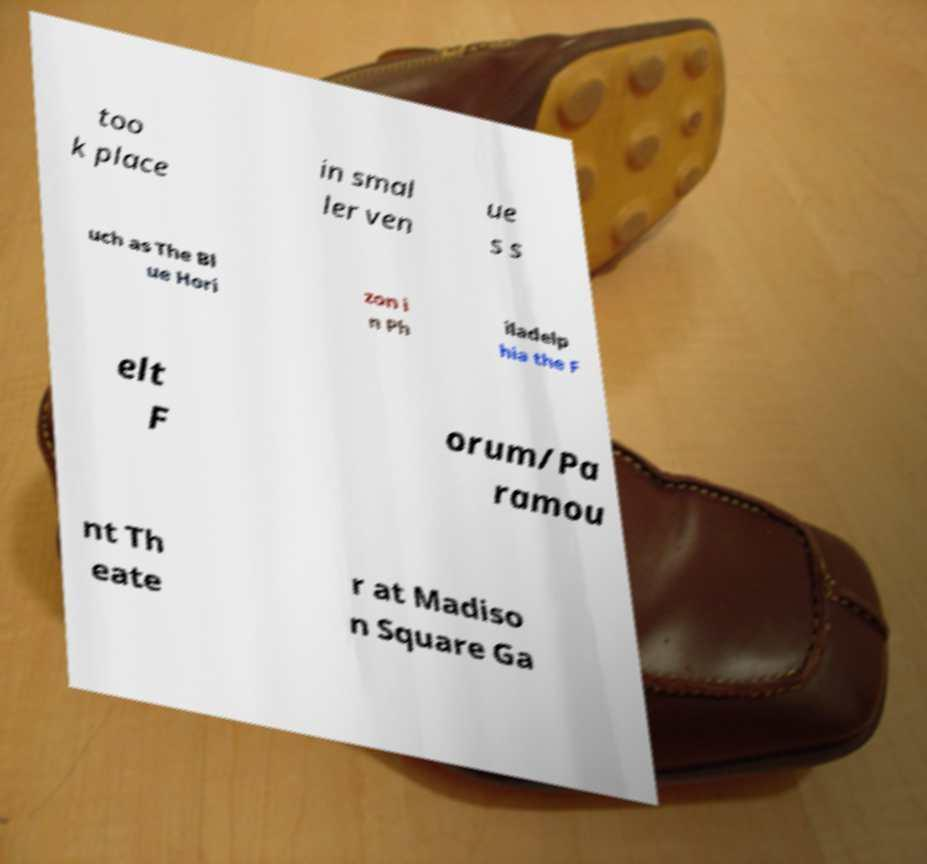Can you read and provide the text displayed in the image?This photo seems to have some interesting text. Can you extract and type it out for me? too k place in smal ler ven ue s s uch as The Bl ue Hori zon i n Ph iladelp hia the F elt F orum/Pa ramou nt Th eate r at Madiso n Square Ga 